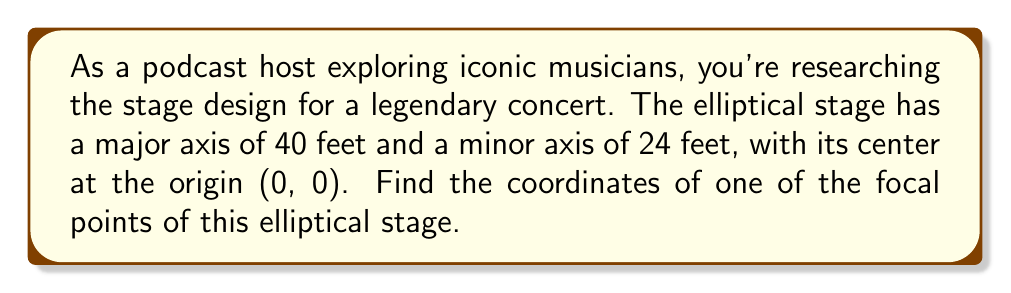Could you help me with this problem? Let's approach this step-by-step:

1) The equation of an ellipse centered at the origin is:

   $$\frac{x^2}{a^2} + \frac{y^2}{b^2} = 1$$

   where $a$ is half the length of the major axis and $b$ is half the length of the minor axis.

2) In this case:
   $a = 40/2 = 20$ feet
   $b = 24/2 = 12$ feet

3) For an ellipse, the relationship between $a$, $b$, and the distance $c$ from the center to a focal point is:

   $$c^2 = a^2 - b^2$$

4) Let's calculate $c$:

   $$c^2 = 20^2 - 12^2 = 400 - 144 = 256$$
   $$c = \sqrt{256} = 16$$

5) The focal points of an ellipse centered at the origin are located at $(±c, 0)$.

6) Therefore, one focal point is at $(16, 0)$ and the other is at $(-16, 0)$.

[asy]
unitsize(5mm);
draw(ellipse((0,0),20,12));
dot((16,0),red);
dot((-16,0),red);
dot((0,0),blue);
label("(16,0)",(16,0),E);
label("(-16,0)",(-16,0),W);
label("(0,0)",(0,0),S);
draw((-20,0)--(20,0),dashed);
draw((0,-12)--(0,12),dashed);
[/asy]
Answer: $(16, 0)$ or $(-16, 0)$ 